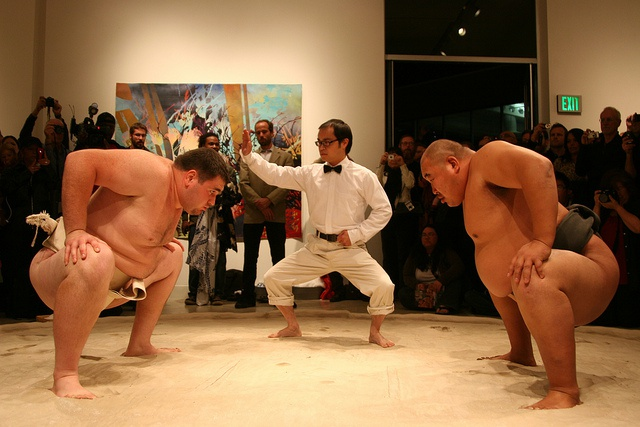Describe the objects in this image and their specific colors. I can see people in maroon, brown, tan, salmon, and red tones, people in maroon, brown, and black tones, people in maroon, black, and gray tones, people in maroon, tan, and brown tones, and people in maroon, black, and brown tones in this image. 